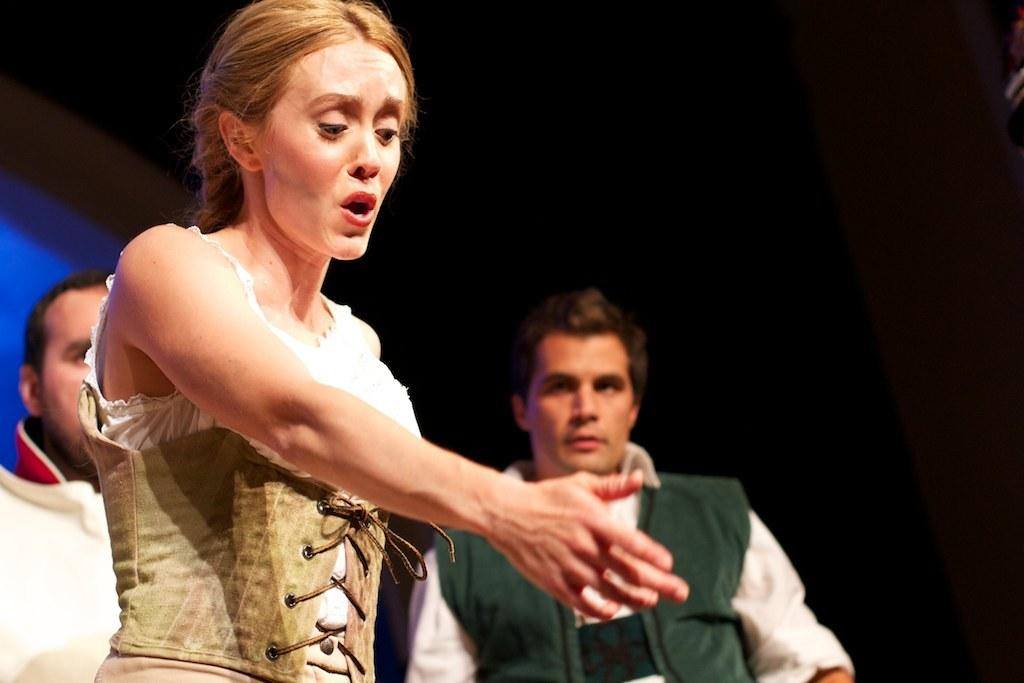How many people are in the image? There are two men and a woman in the image. What is the woman doing in the image? The woman is stretching her hand out. What can be observed about the background of the image? The background of the image is dark. What type of country is depicted in the background of the image? There is no country depicted in the background of the image; it is dark. Can you tell me how many bottles are visible in the image? There are no bottles present in the image. 